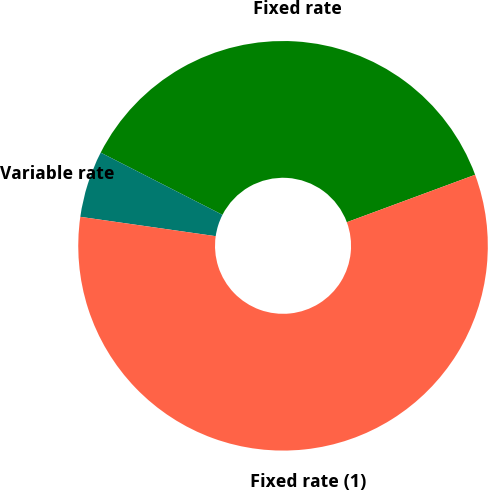Convert chart to OTSL. <chart><loc_0><loc_0><loc_500><loc_500><pie_chart><fcel>Fixed rate<fcel>Variable rate<fcel>Fixed rate (1)<nl><fcel>36.84%<fcel>5.26%<fcel>57.89%<nl></chart> 